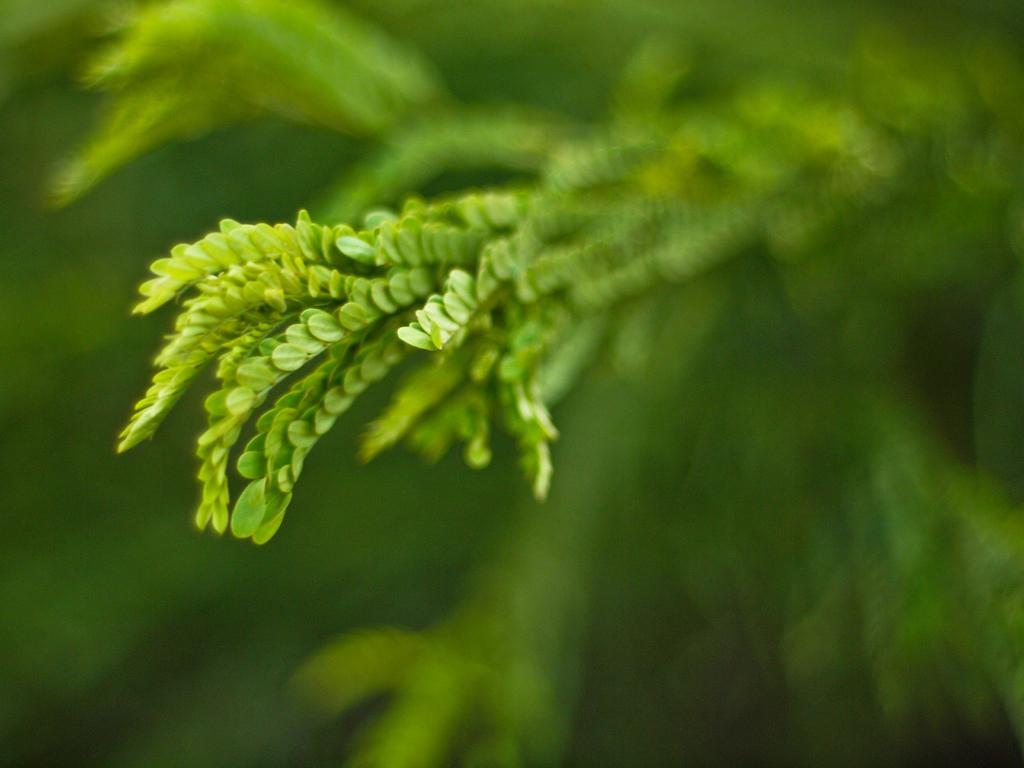In one or two sentences, can you explain what this image depicts? In this picture we can see leaves and blurry background. 